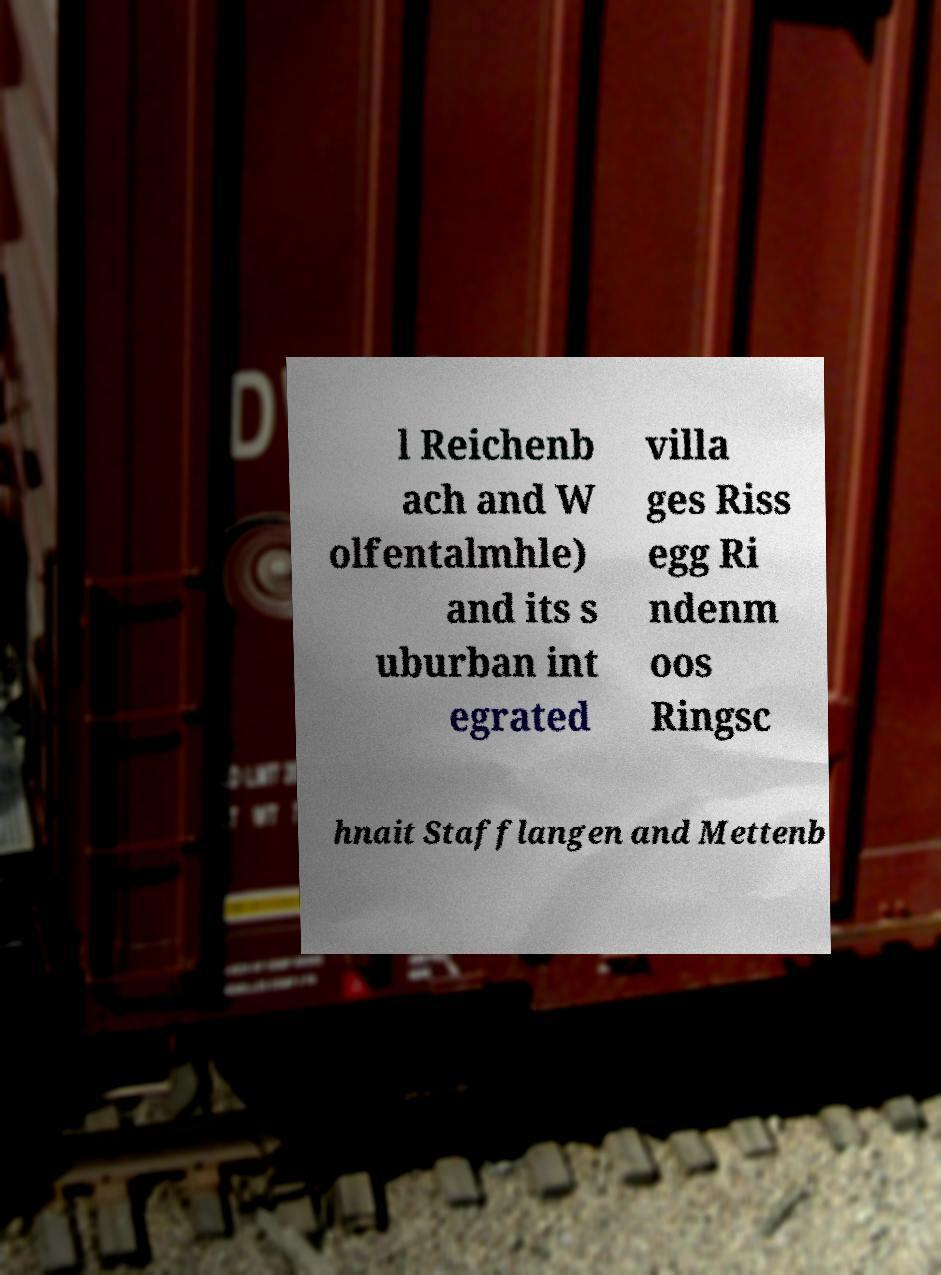Please identify and transcribe the text found in this image. l Reichenb ach and W olfentalmhle) and its s uburban int egrated villa ges Riss egg Ri ndenm oos Ringsc hnait Stafflangen and Mettenb 